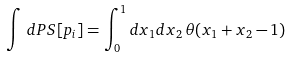Convert formula to latex. <formula><loc_0><loc_0><loc_500><loc_500>\int \, d P S [ p _ { i } ] = \int _ { 0 } ^ { 1 } d x _ { 1 } d x _ { 2 } \, \theta ( x _ { 1 } + x _ { 2 } - 1 ) \,</formula> 